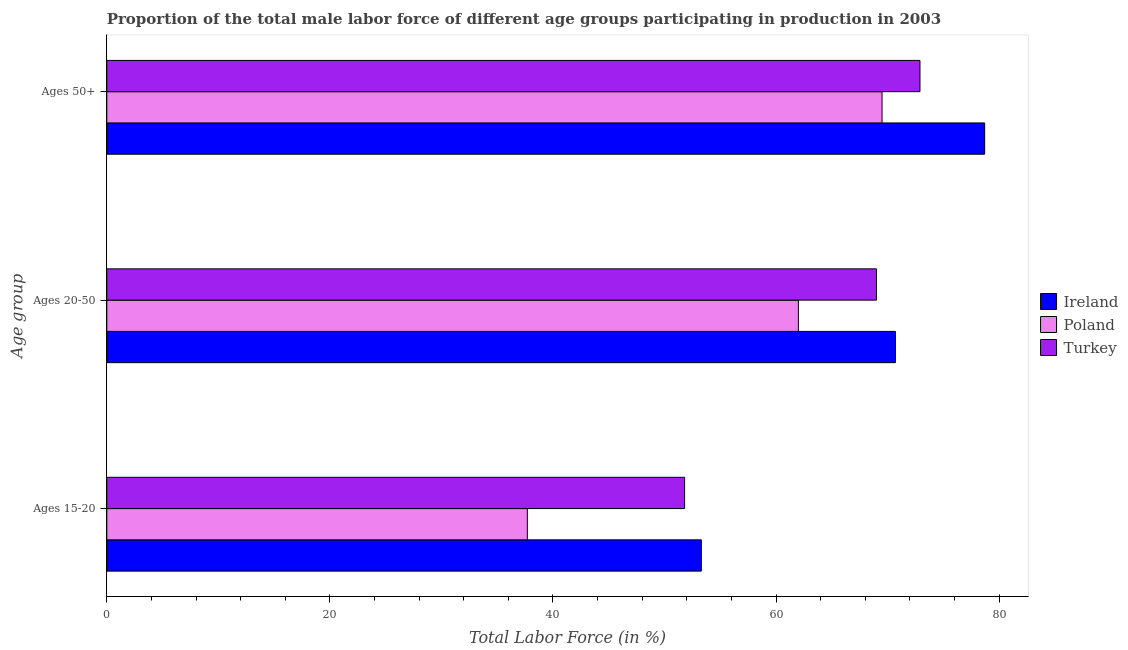How many different coloured bars are there?
Ensure brevity in your answer.  3. Are the number of bars per tick equal to the number of legend labels?
Offer a terse response. Yes. Are the number of bars on each tick of the Y-axis equal?
Offer a terse response. Yes. What is the label of the 2nd group of bars from the top?
Offer a terse response. Ages 20-50. What is the percentage of male labor force above age 50 in Ireland?
Your answer should be compact. 78.7. Across all countries, what is the maximum percentage of male labor force within the age group 15-20?
Provide a short and direct response. 53.3. Across all countries, what is the minimum percentage of male labor force within the age group 20-50?
Your answer should be compact. 62. In which country was the percentage of male labor force above age 50 maximum?
Offer a very short reply. Ireland. What is the total percentage of male labor force within the age group 15-20 in the graph?
Offer a terse response. 142.8. What is the difference between the percentage of male labor force within the age group 20-50 in Poland and that in Turkey?
Provide a succinct answer. -7. What is the difference between the percentage of male labor force within the age group 20-50 in Turkey and the percentage of male labor force within the age group 15-20 in Ireland?
Provide a succinct answer. 15.7. What is the average percentage of male labor force within the age group 15-20 per country?
Provide a short and direct response. 47.6. In how many countries, is the percentage of male labor force within the age group 20-50 greater than 48 %?
Your response must be concise. 3. What is the ratio of the percentage of male labor force above age 50 in Poland to that in Turkey?
Your answer should be compact. 0.95. What is the difference between the highest and the second highest percentage of male labor force above age 50?
Ensure brevity in your answer.  5.8. What is the difference between the highest and the lowest percentage of male labor force above age 50?
Offer a very short reply. 9.2. In how many countries, is the percentage of male labor force above age 50 greater than the average percentage of male labor force above age 50 taken over all countries?
Provide a short and direct response. 1. Is the sum of the percentage of male labor force within the age group 20-50 in Poland and Ireland greater than the maximum percentage of male labor force within the age group 15-20 across all countries?
Provide a succinct answer. Yes. What does the 3rd bar from the top in Ages 20-50 represents?
Offer a terse response. Ireland. What does the 1st bar from the bottom in Ages 50+ represents?
Offer a terse response. Ireland. Is it the case that in every country, the sum of the percentage of male labor force within the age group 15-20 and percentage of male labor force within the age group 20-50 is greater than the percentage of male labor force above age 50?
Your answer should be very brief. Yes. How many countries are there in the graph?
Provide a short and direct response. 3. What is the difference between two consecutive major ticks on the X-axis?
Provide a short and direct response. 20. Does the graph contain any zero values?
Ensure brevity in your answer.  No. Where does the legend appear in the graph?
Ensure brevity in your answer.  Center right. What is the title of the graph?
Offer a terse response. Proportion of the total male labor force of different age groups participating in production in 2003. Does "Netherlands" appear as one of the legend labels in the graph?
Keep it short and to the point. No. What is the label or title of the X-axis?
Give a very brief answer. Total Labor Force (in %). What is the label or title of the Y-axis?
Your answer should be compact. Age group. What is the Total Labor Force (in %) in Ireland in Ages 15-20?
Your response must be concise. 53.3. What is the Total Labor Force (in %) in Poland in Ages 15-20?
Ensure brevity in your answer.  37.7. What is the Total Labor Force (in %) in Turkey in Ages 15-20?
Ensure brevity in your answer.  51.8. What is the Total Labor Force (in %) of Ireland in Ages 20-50?
Give a very brief answer. 70.7. What is the Total Labor Force (in %) in Poland in Ages 20-50?
Offer a very short reply. 62. What is the Total Labor Force (in %) in Turkey in Ages 20-50?
Provide a short and direct response. 69. What is the Total Labor Force (in %) in Ireland in Ages 50+?
Your response must be concise. 78.7. What is the Total Labor Force (in %) in Poland in Ages 50+?
Provide a short and direct response. 69.5. What is the Total Labor Force (in %) in Turkey in Ages 50+?
Offer a terse response. 72.9. Across all Age group, what is the maximum Total Labor Force (in %) of Ireland?
Offer a terse response. 78.7. Across all Age group, what is the maximum Total Labor Force (in %) in Poland?
Your answer should be compact. 69.5. Across all Age group, what is the maximum Total Labor Force (in %) in Turkey?
Give a very brief answer. 72.9. Across all Age group, what is the minimum Total Labor Force (in %) of Ireland?
Offer a very short reply. 53.3. Across all Age group, what is the minimum Total Labor Force (in %) of Poland?
Offer a very short reply. 37.7. Across all Age group, what is the minimum Total Labor Force (in %) in Turkey?
Keep it short and to the point. 51.8. What is the total Total Labor Force (in %) in Ireland in the graph?
Provide a short and direct response. 202.7. What is the total Total Labor Force (in %) in Poland in the graph?
Provide a short and direct response. 169.2. What is the total Total Labor Force (in %) of Turkey in the graph?
Your response must be concise. 193.7. What is the difference between the Total Labor Force (in %) in Ireland in Ages 15-20 and that in Ages 20-50?
Your answer should be very brief. -17.4. What is the difference between the Total Labor Force (in %) in Poland in Ages 15-20 and that in Ages 20-50?
Offer a very short reply. -24.3. What is the difference between the Total Labor Force (in %) in Turkey in Ages 15-20 and that in Ages 20-50?
Offer a terse response. -17.2. What is the difference between the Total Labor Force (in %) of Ireland in Ages 15-20 and that in Ages 50+?
Provide a succinct answer. -25.4. What is the difference between the Total Labor Force (in %) of Poland in Ages 15-20 and that in Ages 50+?
Offer a very short reply. -31.8. What is the difference between the Total Labor Force (in %) in Turkey in Ages 15-20 and that in Ages 50+?
Ensure brevity in your answer.  -21.1. What is the difference between the Total Labor Force (in %) of Turkey in Ages 20-50 and that in Ages 50+?
Provide a succinct answer. -3.9. What is the difference between the Total Labor Force (in %) in Ireland in Ages 15-20 and the Total Labor Force (in %) in Poland in Ages 20-50?
Ensure brevity in your answer.  -8.7. What is the difference between the Total Labor Force (in %) in Ireland in Ages 15-20 and the Total Labor Force (in %) in Turkey in Ages 20-50?
Offer a very short reply. -15.7. What is the difference between the Total Labor Force (in %) of Poland in Ages 15-20 and the Total Labor Force (in %) of Turkey in Ages 20-50?
Your answer should be compact. -31.3. What is the difference between the Total Labor Force (in %) in Ireland in Ages 15-20 and the Total Labor Force (in %) in Poland in Ages 50+?
Offer a very short reply. -16.2. What is the difference between the Total Labor Force (in %) in Ireland in Ages 15-20 and the Total Labor Force (in %) in Turkey in Ages 50+?
Give a very brief answer. -19.6. What is the difference between the Total Labor Force (in %) of Poland in Ages 15-20 and the Total Labor Force (in %) of Turkey in Ages 50+?
Give a very brief answer. -35.2. What is the difference between the Total Labor Force (in %) in Ireland in Ages 20-50 and the Total Labor Force (in %) in Turkey in Ages 50+?
Provide a succinct answer. -2.2. What is the difference between the Total Labor Force (in %) of Poland in Ages 20-50 and the Total Labor Force (in %) of Turkey in Ages 50+?
Keep it short and to the point. -10.9. What is the average Total Labor Force (in %) of Ireland per Age group?
Your response must be concise. 67.57. What is the average Total Labor Force (in %) in Poland per Age group?
Your answer should be very brief. 56.4. What is the average Total Labor Force (in %) in Turkey per Age group?
Ensure brevity in your answer.  64.57. What is the difference between the Total Labor Force (in %) in Poland and Total Labor Force (in %) in Turkey in Ages 15-20?
Make the answer very short. -14.1. What is the difference between the Total Labor Force (in %) in Ireland and Total Labor Force (in %) in Poland in Ages 20-50?
Offer a terse response. 8.7. What is the difference between the Total Labor Force (in %) in Ireland and Total Labor Force (in %) in Poland in Ages 50+?
Provide a short and direct response. 9.2. What is the difference between the Total Labor Force (in %) in Ireland and Total Labor Force (in %) in Turkey in Ages 50+?
Make the answer very short. 5.8. What is the ratio of the Total Labor Force (in %) in Ireland in Ages 15-20 to that in Ages 20-50?
Keep it short and to the point. 0.75. What is the ratio of the Total Labor Force (in %) of Poland in Ages 15-20 to that in Ages 20-50?
Offer a very short reply. 0.61. What is the ratio of the Total Labor Force (in %) in Turkey in Ages 15-20 to that in Ages 20-50?
Your answer should be compact. 0.75. What is the ratio of the Total Labor Force (in %) of Ireland in Ages 15-20 to that in Ages 50+?
Offer a terse response. 0.68. What is the ratio of the Total Labor Force (in %) in Poland in Ages 15-20 to that in Ages 50+?
Your answer should be very brief. 0.54. What is the ratio of the Total Labor Force (in %) of Turkey in Ages 15-20 to that in Ages 50+?
Make the answer very short. 0.71. What is the ratio of the Total Labor Force (in %) in Ireland in Ages 20-50 to that in Ages 50+?
Keep it short and to the point. 0.9. What is the ratio of the Total Labor Force (in %) of Poland in Ages 20-50 to that in Ages 50+?
Your response must be concise. 0.89. What is the ratio of the Total Labor Force (in %) of Turkey in Ages 20-50 to that in Ages 50+?
Your answer should be compact. 0.95. What is the difference between the highest and the second highest Total Labor Force (in %) of Ireland?
Keep it short and to the point. 8. What is the difference between the highest and the second highest Total Labor Force (in %) in Poland?
Provide a short and direct response. 7.5. What is the difference between the highest and the second highest Total Labor Force (in %) of Turkey?
Give a very brief answer. 3.9. What is the difference between the highest and the lowest Total Labor Force (in %) in Ireland?
Your response must be concise. 25.4. What is the difference between the highest and the lowest Total Labor Force (in %) in Poland?
Provide a short and direct response. 31.8. What is the difference between the highest and the lowest Total Labor Force (in %) of Turkey?
Give a very brief answer. 21.1. 